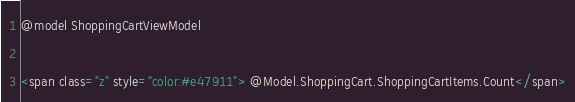Convert code to text. <code><loc_0><loc_0><loc_500><loc_500><_C#_>@model ShoppingCartViewModel

<span class="z" style="color:#e47911"> @Model.ShoppingCart.ShoppingCartItems.Count</span>

</code> 